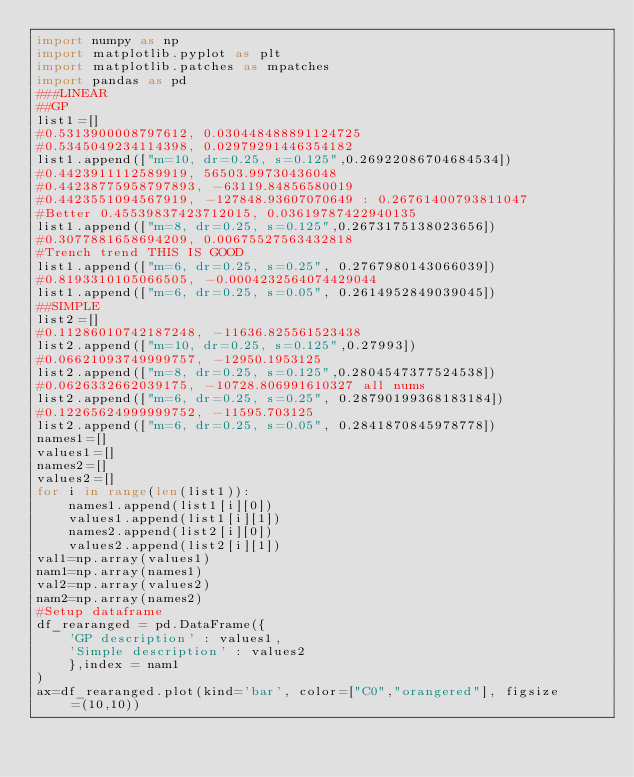Convert code to text. <code><loc_0><loc_0><loc_500><loc_500><_Python_>import numpy as np
import matplotlib.pyplot as plt
import matplotlib.patches as mpatches
import pandas as pd
###LINEAR
##GP
list1=[]
#0.5313900008797612, 0.030448488891124725
#0.5345049234114398, 0.02979291446354182
list1.append(["m=10, dr=0.25, s=0.125",0.26922086704684534])
#0.4423911112589919, 56503.99730436048
#0.44238775958797893, -63119.84856580019
#0.4423551094567919, -127848.93607070649 : 0.26761400793811047
#Better 0.45539837423712015, 0.03619787422940135
list1.append(["m=8, dr=0.25, s=0.125",0.2673175138023656])
#0.3077881658694209, 0.00675527563432818
#Trench trend THIS IS GOOD
list1.append(["m=6, dr=0.25, s=0.25", 0.2767980143066039])
#0.8193310105066505, -0.0004232564074429044
list1.append(["m=6, dr=0.25, s=0.05", 0.2614952849039045])
##SIMPLE
list2=[]
#0.11286010742187248, -11636.825561523438
list2.append(["m=10, dr=0.25, s=0.125",0.27993])
#0.06621093749999757, -12950.1953125
list2.append(["m=8, dr=0.25, s=0.125",0.2804547377524538])
#0.0626332662039175, -10728.806991610327 all nums
list2.append(["m=6, dr=0.25, s=0.25", 0.28790199368183184])
#0.12265624999999752, -11595.703125
list2.append(["m=6, dr=0.25, s=0.05", 0.2841870845978778])
names1=[]
values1=[]
names2=[]
values2=[]
for i in range(len(list1)):
    names1.append(list1[i][0])
    values1.append(list1[i][1])
    names2.append(list2[i][0])
    values2.append(list2[i][1])
val1=np.array(values1)
nam1=np.array(names1)
val2=np.array(values2)
nam2=np.array(names2)
#Setup dataframe
df_rearanged = pd.DataFrame({
    'GP description' : values1,
    'Simple description' : values2
    },index = nam1
)
ax=df_rearanged.plot(kind='bar', color=["C0","orangered"], figsize=(10,10))
</code> 